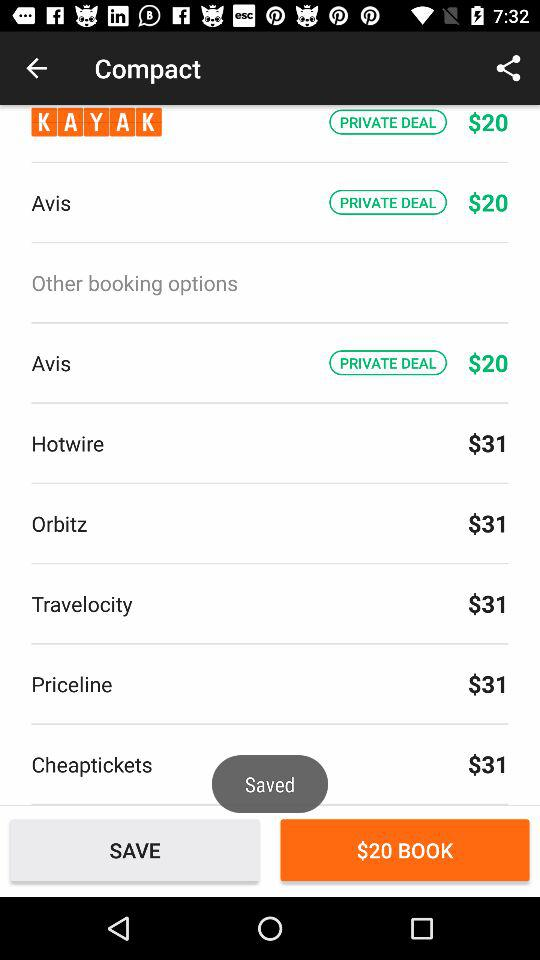What's the booking price? The booking price is $20. 